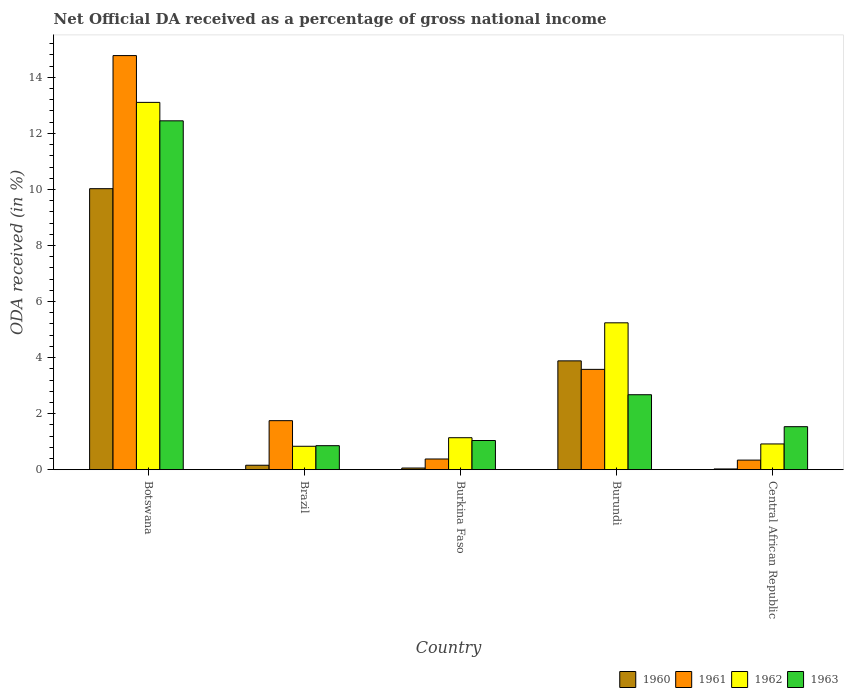How many groups of bars are there?
Your answer should be compact. 5. Are the number of bars per tick equal to the number of legend labels?
Your answer should be very brief. Yes. How many bars are there on the 5th tick from the left?
Give a very brief answer. 4. What is the label of the 2nd group of bars from the left?
Your answer should be compact. Brazil. In how many cases, is the number of bars for a given country not equal to the number of legend labels?
Offer a very short reply. 0. What is the net official DA received in 1963 in Burkina Faso?
Keep it short and to the point. 1.04. Across all countries, what is the maximum net official DA received in 1961?
Give a very brief answer. 14.78. Across all countries, what is the minimum net official DA received in 1960?
Your response must be concise. 0.03. In which country was the net official DA received in 1960 maximum?
Give a very brief answer. Botswana. In which country was the net official DA received in 1962 minimum?
Your response must be concise. Brazil. What is the total net official DA received in 1961 in the graph?
Your answer should be very brief. 20.83. What is the difference between the net official DA received in 1963 in Burkina Faso and that in Burundi?
Provide a short and direct response. -1.63. What is the difference between the net official DA received in 1960 in Botswana and the net official DA received in 1961 in Brazil?
Your answer should be compact. 8.28. What is the average net official DA received in 1963 per country?
Provide a succinct answer. 3.71. What is the difference between the net official DA received of/in 1963 and net official DA received of/in 1960 in Botswana?
Your answer should be compact. 2.42. What is the ratio of the net official DA received in 1962 in Botswana to that in Burundi?
Offer a terse response. 2.5. Is the difference between the net official DA received in 1963 in Burundi and Central African Republic greater than the difference between the net official DA received in 1960 in Burundi and Central African Republic?
Provide a succinct answer. No. What is the difference between the highest and the second highest net official DA received in 1961?
Give a very brief answer. -1.83. What is the difference between the highest and the lowest net official DA received in 1961?
Give a very brief answer. 14.43. Is it the case that in every country, the sum of the net official DA received in 1962 and net official DA received in 1961 is greater than the sum of net official DA received in 1960 and net official DA received in 1963?
Your response must be concise. No. Is it the case that in every country, the sum of the net official DA received in 1963 and net official DA received in 1962 is greater than the net official DA received in 1961?
Your answer should be compact. No. How many bars are there?
Ensure brevity in your answer.  20. Are all the bars in the graph horizontal?
Provide a succinct answer. No. How many countries are there in the graph?
Provide a short and direct response. 5. What is the difference between two consecutive major ticks on the Y-axis?
Make the answer very short. 2. Does the graph contain any zero values?
Offer a terse response. No. Does the graph contain grids?
Offer a terse response. No. How are the legend labels stacked?
Offer a very short reply. Horizontal. What is the title of the graph?
Make the answer very short. Net Official DA received as a percentage of gross national income. What is the label or title of the X-axis?
Your answer should be compact. Country. What is the label or title of the Y-axis?
Give a very brief answer. ODA received (in %). What is the ODA received (in %) in 1960 in Botswana?
Ensure brevity in your answer.  10.03. What is the ODA received (in %) of 1961 in Botswana?
Ensure brevity in your answer.  14.78. What is the ODA received (in %) in 1962 in Botswana?
Provide a succinct answer. 13.11. What is the ODA received (in %) of 1963 in Botswana?
Your response must be concise. 12.45. What is the ODA received (in %) in 1960 in Brazil?
Make the answer very short. 0.16. What is the ODA received (in %) of 1961 in Brazil?
Provide a short and direct response. 1.75. What is the ODA received (in %) in 1962 in Brazil?
Provide a succinct answer. 0.84. What is the ODA received (in %) in 1963 in Brazil?
Give a very brief answer. 0.86. What is the ODA received (in %) of 1960 in Burkina Faso?
Your answer should be very brief. 0.06. What is the ODA received (in %) in 1961 in Burkina Faso?
Your answer should be compact. 0.38. What is the ODA received (in %) in 1962 in Burkina Faso?
Provide a succinct answer. 1.14. What is the ODA received (in %) of 1963 in Burkina Faso?
Your answer should be very brief. 1.04. What is the ODA received (in %) in 1960 in Burundi?
Your answer should be compact. 3.88. What is the ODA received (in %) in 1961 in Burundi?
Your response must be concise. 3.58. What is the ODA received (in %) of 1962 in Burundi?
Provide a short and direct response. 5.24. What is the ODA received (in %) of 1963 in Burundi?
Make the answer very short. 2.68. What is the ODA received (in %) in 1960 in Central African Republic?
Keep it short and to the point. 0.03. What is the ODA received (in %) in 1961 in Central African Republic?
Your response must be concise. 0.34. What is the ODA received (in %) of 1962 in Central African Republic?
Your answer should be compact. 0.92. What is the ODA received (in %) of 1963 in Central African Republic?
Offer a very short reply. 1.54. Across all countries, what is the maximum ODA received (in %) in 1960?
Your answer should be very brief. 10.03. Across all countries, what is the maximum ODA received (in %) of 1961?
Provide a short and direct response. 14.78. Across all countries, what is the maximum ODA received (in %) of 1962?
Your answer should be compact. 13.11. Across all countries, what is the maximum ODA received (in %) of 1963?
Keep it short and to the point. 12.45. Across all countries, what is the minimum ODA received (in %) in 1960?
Your answer should be very brief. 0.03. Across all countries, what is the minimum ODA received (in %) in 1961?
Your answer should be very brief. 0.34. Across all countries, what is the minimum ODA received (in %) in 1962?
Provide a succinct answer. 0.84. Across all countries, what is the minimum ODA received (in %) in 1963?
Ensure brevity in your answer.  0.86. What is the total ODA received (in %) of 1960 in the graph?
Offer a very short reply. 14.16. What is the total ODA received (in %) of 1961 in the graph?
Your answer should be very brief. 20.83. What is the total ODA received (in %) in 1962 in the graph?
Your response must be concise. 21.24. What is the total ODA received (in %) in 1963 in the graph?
Provide a succinct answer. 18.56. What is the difference between the ODA received (in %) of 1960 in Botswana and that in Brazil?
Ensure brevity in your answer.  9.87. What is the difference between the ODA received (in %) in 1961 in Botswana and that in Brazil?
Your answer should be compact. 13.03. What is the difference between the ODA received (in %) of 1962 in Botswana and that in Brazil?
Keep it short and to the point. 12.27. What is the difference between the ODA received (in %) of 1963 in Botswana and that in Brazil?
Ensure brevity in your answer.  11.59. What is the difference between the ODA received (in %) of 1960 in Botswana and that in Burkina Faso?
Offer a terse response. 9.97. What is the difference between the ODA received (in %) of 1961 in Botswana and that in Burkina Faso?
Keep it short and to the point. 14.39. What is the difference between the ODA received (in %) of 1962 in Botswana and that in Burkina Faso?
Your answer should be compact. 11.97. What is the difference between the ODA received (in %) in 1963 in Botswana and that in Burkina Faso?
Your answer should be very brief. 11.41. What is the difference between the ODA received (in %) in 1960 in Botswana and that in Burundi?
Make the answer very short. 6.14. What is the difference between the ODA received (in %) of 1961 in Botswana and that in Burundi?
Ensure brevity in your answer.  11.2. What is the difference between the ODA received (in %) in 1962 in Botswana and that in Burundi?
Make the answer very short. 7.87. What is the difference between the ODA received (in %) of 1963 in Botswana and that in Burundi?
Provide a short and direct response. 9.77. What is the difference between the ODA received (in %) of 1960 in Botswana and that in Central African Republic?
Offer a very short reply. 10. What is the difference between the ODA received (in %) in 1961 in Botswana and that in Central African Republic?
Ensure brevity in your answer.  14.43. What is the difference between the ODA received (in %) of 1962 in Botswana and that in Central African Republic?
Your answer should be compact. 12.19. What is the difference between the ODA received (in %) in 1963 in Botswana and that in Central African Republic?
Your answer should be very brief. 10.91. What is the difference between the ODA received (in %) in 1960 in Brazil and that in Burkina Faso?
Offer a terse response. 0.1. What is the difference between the ODA received (in %) in 1961 in Brazil and that in Burkina Faso?
Make the answer very short. 1.37. What is the difference between the ODA received (in %) of 1962 in Brazil and that in Burkina Faso?
Your response must be concise. -0.31. What is the difference between the ODA received (in %) of 1963 in Brazil and that in Burkina Faso?
Give a very brief answer. -0.18. What is the difference between the ODA received (in %) of 1960 in Brazil and that in Burundi?
Give a very brief answer. -3.72. What is the difference between the ODA received (in %) of 1961 in Brazil and that in Burundi?
Ensure brevity in your answer.  -1.83. What is the difference between the ODA received (in %) in 1962 in Brazil and that in Burundi?
Provide a succinct answer. -4.41. What is the difference between the ODA received (in %) of 1963 in Brazil and that in Burundi?
Offer a terse response. -1.82. What is the difference between the ODA received (in %) in 1960 in Brazil and that in Central African Republic?
Offer a terse response. 0.13. What is the difference between the ODA received (in %) in 1961 in Brazil and that in Central African Republic?
Ensure brevity in your answer.  1.41. What is the difference between the ODA received (in %) in 1962 in Brazil and that in Central African Republic?
Provide a short and direct response. -0.08. What is the difference between the ODA received (in %) of 1963 in Brazil and that in Central African Republic?
Give a very brief answer. -0.68. What is the difference between the ODA received (in %) in 1960 in Burkina Faso and that in Burundi?
Provide a short and direct response. -3.82. What is the difference between the ODA received (in %) of 1961 in Burkina Faso and that in Burundi?
Offer a very short reply. -3.2. What is the difference between the ODA received (in %) of 1962 in Burkina Faso and that in Burundi?
Ensure brevity in your answer.  -4.1. What is the difference between the ODA received (in %) in 1963 in Burkina Faso and that in Burundi?
Provide a succinct answer. -1.63. What is the difference between the ODA received (in %) in 1960 in Burkina Faso and that in Central African Republic?
Ensure brevity in your answer.  0.03. What is the difference between the ODA received (in %) in 1961 in Burkina Faso and that in Central African Republic?
Make the answer very short. 0.04. What is the difference between the ODA received (in %) in 1962 in Burkina Faso and that in Central African Republic?
Provide a short and direct response. 0.22. What is the difference between the ODA received (in %) of 1963 in Burkina Faso and that in Central African Republic?
Provide a succinct answer. -0.49. What is the difference between the ODA received (in %) of 1960 in Burundi and that in Central African Republic?
Ensure brevity in your answer.  3.86. What is the difference between the ODA received (in %) of 1961 in Burundi and that in Central African Republic?
Make the answer very short. 3.24. What is the difference between the ODA received (in %) in 1962 in Burundi and that in Central African Republic?
Offer a very short reply. 4.32. What is the difference between the ODA received (in %) of 1963 in Burundi and that in Central African Republic?
Offer a terse response. 1.14. What is the difference between the ODA received (in %) in 1960 in Botswana and the ODA received (in %) in 1961 in Brazil?
Provide a succinct answer. 8.28. What is the difference between the ODA received (in %) in 1960 in Botswana and the ODA received (in %) in 1962 in Brazil?
Provide a short and direct response. 9.19. What is the difference between the ODA received (in %) of 1960 in Botswana and the ODA received (in %) of 1963 in Brazil?
Offer a terse response. 9.17. What is the difference between the ODA received (in %) of 1961 in Botswana and the ODA received (in %) of 1962 in Brazil?
Provide a short and direct response. 13.94. What is the difference between the ODA received (in %) in 1961 in Botswana and the ODA received (in %) in 1963 in Brazil?
Give a very brief answer. 13.92. What is the difference between the ODA received (in %) of 1962 in Botswana and the ODA received (in %) of 1963 in Brazil?
Provide a short and direct response. 12.25. What is the difference between the ODA received (in %) in 1960 in Botswana and the ODA received (in %) in 1961 in Burkina Faso?
Make the answer very short. 9.65. What is the difference between the ODA received (in %) of 1960 in Botswana and the ODA received (in %) of 1962 in Burkina Faso?
Your response must be concise. 8.89. What is the difference between the ODA received (in %) in 1960 in Botswana and the ODA received (in %) in 1963 in Burkina Faso?
Your answer should be compact. 8.99. What is the difference between the ODA received (in %) of 1961 in Botswana and the ODA received (in %) of 1962 in Burkina Faso?
Provide a succinct answer. 13.64. What is the difference between the ODA received (in %) in 1961 in Botswana and the ODA received (in %) in 1963 in Burkina Faso?
Offer a very short reply. 13.74. What is the difference between the ODA received (in %) in 1962 in Botswana and the ODA received (in %) in 1963 in Burkina Faso?
Give a very brief answer. 12.07. What is the difference between the ODA received (in %) in 1960 in Botswana and the ODA received (in %) in 1961 in Burundi?
Your answer should be very brief. 6.45. What is the difference between the ODA received (in %) in 1960 in Botswana and the ODA received (in %) in 1962 in Burundi?
Offer a very short reply. 4.79. What is the difference between the ODA received (in %) in 1960 in Botswana and the ODA received (in %) in 1963 in Burundi?
Your response must be concise. 7.35. What is the difference between the ODA received (in %) in 1961 in Botswana and the ODA received (in %) in 1962 in Burundi?
Offer a terse response. 9.54. What is the difference between the ODA received (in %) in 1961 in Botswana and the ODA received (in %) in 1963 in Burundi?
Offer a terse response. 12.1. What is the difference between the ODA received (in %) in 1962 in Botswana and the ODA received (in %) in 1963 in Burundi?
Offer a terse response. 10.43. What is the difference between the ODA received (in %) of 1960 in Botswana and the ODA received (in %) of 1961 in Central African Republic?
Your answer should be compact. 9.69. What is the difference between the ODA received (in %) of 1960 in Botswana and the ODA received (in %) of 1962 in Central African Republic?
Give a very brief answer. 9.11. What is the difference between the ODA received (in %) of 1960 in Botswana and the ODA received (in %) of 1963 in Central African Republic?
Give a very brief answer. 8.49. What is the difference between the ODA received (in %) of 1961 in Botswana and the ODA received (in %) of 1962 in Central African Republic?
Your answer should be compact. 13.86. What is the difference between the ODA received (in %) of 1961 in Botswana and the ODA received (in %) of 1963 in Central African Republic?
Your answer should be compact. 13.24. What is the difference between the ODA received (in %) of 1962 in Botswana and the ODA received (in %) of 1963 in Central African Republic?
Give a very brief answer. 11.57. What is the difference between the ODA received (in %) in 1960 in Brazil and the ODA received (in %) in 1961 in Burkina Faso?
Make the answer very short. -0.22. What is the difference between the ODA received (in %) of 1960 in Brazil and the ODA received (in %) of 1962 in Burkina Faso?
Your answer should be very brief. -0.98. What is the difference between the ODA received (in %) in 1960 in Brazil and the ODA received (in %) in 1963 in Burkina Faso?
Keep it short and to the point. -0.88. What is the difference between the ODA received (in %) of 1961 in Brazil and the ODA received (in %) of 1962 in Burkina Faso?
Keep it short and to the point. 0.61. What is the difference between the ODA received (in %) of 1961 in Brazil and the ODA received (in %) of 1963 in Burkina Faso?
Offer a terse response. 0.71. What is the difference between the ODA received (in %) of 1962 in Brazil and the ODA received (in %) of 1963 in Burkina Faso?
Ensure brevity in your answer.  -0.21. What is the difference between the ODA received (in %) of 1960 in Brazil and the ODA received (in %) of 1961 in Burundi?
Give a very brief answer. -3.42. What is the difference between the ODA received (in %) of 1960 in Brazil and the ODA received (in %) of 1962 in Burundi?
Ensure brevity in your answer.  -5.08. What is the difference between the ODA received (in %) in 1960 in Brazil and the ODA received (in %) in 1963 in Burundi?
Keep it short and to the point. -2.52. What is the difference between the ODA received (in %) in 1961 in Brazil and the ODA received (in %) in 1962 in Burundi?
Your response must be concise. -3.49. What is the difference between the ODA received (in %) of 1961 in Brazil and the ODA received (in %) of 1963 in Burundi?
Offer a terse response. -0.93. What is the difference between the ODA received (in %) in 1962 in Brazil and the ODA received (in %) in 1963 in Burundi?
Offer a very short reply. -1.84. What is the difference between the ODA received (in %) of 1960 in Brazil and the ODA received (in %) of 1961 in Central African Republic?
Your answer should be very brief. -0.18. What is the difference between the ODA received (in %) in 1960 in Brazil and the ODA received (in %) in 1962 in Central African Republic?
Your answer should be compact. -0.76. What is the difference between the ODA received (in %) in 1960 in Brazil and the ODA received (in %) in 1963 in Central African Republic?
Keep it short and to the point. -1.38. What is the difference between the ODA received (in %) of 1961 in Brazil and the ODA received (in %) of 1962 in Central African Republic?
Offer a very short reply. 0.83. What is the difference between the ODA received (in %) in 1961 in Brazil and the ODA received (in %) in 1963 in Central African Republic?
Offer a terse response. 0.21. What is the difference between the ODA received (in %) in 1962 in Brazil and the ODA received (in %) in 1963 in Central African Republic?
Your response must be concise. -0.7. What is the difference between the ODA received (in %) of 1960 in Burkina Faso and the ODA received (in %) of 1961 in Burundi?
Provide a short and direct response. -3.52. What is the difference between the ODA received (in %) of 1960 in Burkina Faso and the ODA received (in %) of 1962 in Burundi?
Your response must be concise. -5.18. What is the difference between the ODA received (in %) of 1960 in Burkina Faso and the ODA received (in %) of 1963 in Burundi?
Your response must be concise. -2.62. What is the difference between the ODA received (in %) in 1961 in Burkina Faso and the ODA received (in %) in 1962 in Burundi?
Your answer should be compact. -4.86. What is the difference between the ODA received (in %) of 1961 in Burkina Faso and the ODA received (in %) of 1963 in Burundi?
Provide a short and direct response. -2.29. What is the difference between the ODA received (in %) of 1962 in Burkina Faso and the ODA received (in %) of 1963 in Burundi?
Your answer should be very brief. -1.53. What is the difference between the ODA received (in %) of 1960 in Burkina Faso and the ODA received (in %) of 1961 in Central African Republic?
Offer a very short reply. -0.28. What is the difference between the ODA received (in %) in 1960 in Burkina Faso and the ODA received (in %) in 1962 in Central African Republic?
Offer a very short reply. -0.86. What is the difference between the ODA received (in %) in 1960 in Burkina Faso and the ODA received (in %) in 1963 in Central African Republic?
Provide a succinct answer. -1.48. What is the difference between the ODA received (in %) of 1961 in Burkina Faso and the ODA received (in %) of 1962 in Central African Republic?
Your answer should be compact. -0.54. What is the difference between the ODA received (in %) of 1961 in Burkina Faso and the ODA received (in %) of 1963 in Central African Republic?
Ensure brevity in your answer.  -1.15. What is the difference between the ODA received (in %) in 1962 in Burkina Faso and the ODA received (in %) in 1963 in Central African Republic?
Provide a short and direct response. -0.39. What is the difference between the ODA received (in %) in 1960 in Burundi and the ODA received (in %) in 1961 in Central African Republic?
Your answer should be very brief. 3.54. What is the difference between the ODA received (in %) of 1960 in Burundi and the ODA received (in %) of 1962 in Central African Republic?
Provide a short and direct response. 2.96. What is the difference between the ODA received (in %) of 1960 in Burundi and the ODA received (in %) of 1963 in Central African Republic?
Your answer should be very brief. 2.35. What is the difference between the ODA received (in %) in 1961 in Burundi and the ODA received (in %) in 1962 in Central African Republic?
Give a very brief answer. 2.66. What is the difference between the ODA received (in %) in 1961 in Burundi and the ODA received (in %) in 1963 in Central African Republic?
Make the answer very short. 2.05. What is the difference between the ODA received (in %) in 1962 in Burundi and the ODA received (in %) in 1963 in Central African Republic?
Offer a terse response. 3.71. What is the average ODA received (in %) of 1960 per country?
Offer a terse response. 2.83. What is the average ODA received (in %) in 1961 per country?
Provide a short and direct response. 4.17. What is the average ODA received (in %) in 1962 per country?
Offer a very short reply. 4.25. What is the average ODA received (in %) in 1963 per country?
Give a very brief answer. 3.71. What is the difference between the ODA received (in %) in 1960 and ODA received (in %) in 1961 in Botswana?
Your answer should be compact. -4.75. What is the difference between the ODA received (in %) in 1960 and ODA received (in %) in 1962 in Botswana?
Keep it short and to the point. -3.08. What is the difference between the ODA received (in %) in 1960 and ODA received (in %) in 1963 in Botswana?
Make the answer very short. -2.42. What is the difference between the ODA received (in %) of 1961 and ODA received (in %) of 1962 in Botswana?
Provide a succinct answer. 1.67. What is the difference between the ODA received (in %) of 1961 and ODA received (in %) of 1963 in Botswana?
Your answer should be compact. 2.33. What is the difference between the ODA received (in %) in 1962 and ODA received (in %) in 1963 in Botswana?
Provide a succinct answer. 0.66. What is the difference between the ODA received (in %) of 1960 and ODA received (in %) of 1961 in Brazil?
Give a very brief answer. -1.59. What is the difference between the ODA received (in %) of 1960 and ODA received (in %) of 1962 in Brazil?
Your response must be concise. -0.68. What is the difference between the ODA received (in %) in 1960 and ODA received (in %) in 1963 in Brazil?
Your answer should be very brief. -0.7. What is the difference between the ODA received (in %) of 1961 and ODA received (in %) of 1962 in Brazil?
Give a very brief answer. 0.91. What is the difference between the ODA received (in %) in 1961 and ODA received (in %) in 1963 in Brazil?
Ensure brevity in your answer.  0.89. What is the difference between the ODA received (in %) of 1962 and ODA received (in %) of 1963 in Brazil?
Give a very brief answer. -0.02. What is the difference between the ODA received (in %) in 1960 and ODA received (in %) in 1961 in Burkina Faso?
Offer a terse response. -0.32. What is the difference between the ODA received (in %) in 1960 and ODA received (in %) in 1962 in Burkina Faso?
Your answer should be very brief. -1.08. What is the difference between the ODA received (in %) in 1960 and ODA received (in %) in 1963 in Burkina Faso?
Offer a terse response. -0.98. What is the difference between the ODA received (in %) in 1961 and ODA received (in %) in 1962 in Burkina Faso?
Your answer should be compact. -0.76. What is the difference between the ODA received (in %) of 1961 and ODA received (in %) of 1963 in Burkina Faso?
Ensure brevity in your answer.  -0.66. What is the difference between the ODA received (in %) in 1960 and ODA received (in %) in 1961 in Burundi?
Ensure brevity in your answer.  0.3. What is the difference between the ODA received (in %) of 1960 and ODA received (in %) of 1962 in Burundi?
Your response must be concise. -1.36. What is the difference between the ODA received (in %) in 1960 and ODA received (in %) in 1963 in Burundi?
Provide a succinct answer. 1.21. What is the difference between the ODA received (in %) in 1961 and ODA received (in %) in 1962 in Burundi?
Provide a short and direct response. -1.66. What is the difference between the ODA received (in %) in 1961 and ODA received (in %) in 1963 in Burundi?
Ensure brevity in your answer.  0.91. What is the difference between the ODA received (in %) of 1962 and ODA received (in %) of 1963 in Burundi?
Offer a very short reply. 2.57. What is the difference between the ODA received (in %) in 1960 and ODA received (in %) in 1961 in Central African Republic?
Ensure brevity in your answer.  -0.32. What is the difference between the ODA received (in %) of 1960 and ODA received (in %) of 1962 in Central African Republic?
Your response must be concise. -0.89. What is the difference between the ODA received (in %) in 1960 and ODA received (in %) in 1963 in Central African Republic?
Provide a short and direct response. -1.51. What is the difference between the ODA received (in %) in 1961 and ODA received (in %) in 1962 in Central African Republic?
Your response must be concise. -0.58. What is the difference between the ODA received (in %) in 1961 and ODA received (in %) in 1963 in Central African Republic?
Your answer should be compact. -1.19. What is the difference between the ODA received (in %) of 1962 and ODA received (in %) of 1963 in Central African Republic?
Your answer should be very brief. -0.62. What is the ratio of the ODA received (in %) of 1960 in Botswana to that in Brazil?
Give a very brief answer. 63.08. What is the ratio of the ODA received (in %) in 1961 in Botswana to that in Brazil?
Keep it short and to the point. 8.45. What is the ratio of the ODA received (in %) in 1962 in Botswana to that in Brazil?
Keep it short and to the point. 15.68. What is the ratio of the ODA received (in %) of 1963 in Botswana to that in Brazil?
Keep it short and to the point. 14.53. What is the ratio of the ODA received (in %) of 1960 in Botswana to that in Burkina Faso?
Make the answer very short. 167.91. What is the ratio of the ODA received (in %) in 1961 in Botswana to that in Burkina Faso?
Provide a succinct answer. 38.69. What is the ratio of the ODA received (in %) of 1962 in Botswana to that in Burkina Faso?
Give a very brief answer. 11.48. What is the ratio of the ODA received (in %) in 1963 in Botswana to that in Burkina Faso?
Make the answer very short. 11.95. What is the ratio of the ODA received (in %) of 1960 in Botswana to that in Burundi?
Give a very brief answer. 2.58. What is the ratio of the ODA received (in %) in 1961 in Botswana to that in Burundi?
Your answer should be very brief. 4.13. What is the ratio of the ODA received (in %) of 1962 in Botswana to that in Burundi?
Offer a very short reply. 2.5. What is the ratio of the ODA received (in %) of 1963 in Botswana to that in Burundi?
Make the answer very short. 4.65. What is the ratio of the ODA received (in %) in 1960 in Botswana to that in Central African Republic?
Your response must be concise. 373.52. What is the ratio of the ODA received (in %) in 1961 in Botswana to that in Central African Republic?
Your answer should be very brief. 43.18. What is the ratio of the ODA received (in %) of 1962 in Botswana to that in Central African Republic?
Offer a very short reply. 14.27. What is the ratio of the ODA received (in %) in 1963 in Botswana to that in Central African Republic?
Ensure brevity in your answer.  8.11. What is the ratio of the ODA received (in %) of 1960 in Brazil to that in Burkina Faso?
Your answer should be compact. 2.66. What is the ratio of the ODA received (in %) of 1961 in Brazil to that in Burkina Faso?
Your answer should be very brief. 4.58. What is the ratio of the ODA received (in %) in 1962 in Brazil to that in Burkina Faso?
Make the answer very short. 0.73. What is the ratio of the ODA received (in %) of 1963 in Brazil to that in Burkina Faso?
Make the answer very short. 0.82. What is the ratio of the ODA received (in %) in 1960 in Brazil to that in Burundi?
Provide a short and direct response. 0.04. What is the ratio of the ODA received (in %) in 1961 in Brazil to that in Burundi?
Provide a short and direct response. 0.49. What is the ratio of the ODA received (in %) of 1962 in Brazil to that in Burundi?
Your response must be concise. 0.16. What is the ratio of the ODA received (in %) in 1963 in Brazil to that in Burundi?
Your answer should be very brief. 0.32. What is the ratio of the ODA received (in %) in 1960 in Brazil to that in Central African Republic?
Offer a very short reply. 5.92. What is the ratio of the ODA received (in %) in 1961 in Brazil to that in Central African Republic?
Give a very brief answer. 5.11. What is the ratio of the ODA received (in %) of 1962 in Brazil to that in Central African Republic?
Give a very brief answer. 0.91. What is the ratio of the ODA received (in %) of 1963 in Brazil to that in Central African Republic?
Your response must be concise. 0.56. What is the ratio of the ODA received (in %) of 1960 in Burkina Faso to that in Burundi?
Your answer should be very brief. 0.02. What is the ratio of the ODA received (in %) of 1961 in Burkina Faso to that in Burundi?
Your answer should be compact. 0.11. What is the ratio of the ODA received (in %) of 1962 in Burkina Faso to that in Burundi?
Keep it short and to the point. 0.22. What is the ratio of the ODA received (in %) in 1963 in Burkina Faso to that in Burundi?
Your answer should be very brief. 0.39. What is the ratio of the ODA received (in %) of 1960 in Burkina Faso to that in Central African Republic?
Offer a very short reply. 2.22. What is the ratio of the ODA received (in %) in 1961 in Burkina Faso to that in Central African Republic?
Make the answer very short. 1.12. What is the ratio of the ODA received (in %) of 1962 in Burkina Faso to that in Central African Republic?
Give a very brief answer. 1.24. What is the ratio of the ODA received (in %) of 1963 in Burkina Faso to that in Central African Republic?
Give a very brief answer. 0.68. What is the ratio of the ODA received (in %) of 1960 in Burundi to that in Central African Republic?
Ensure brevity in your answer.  144.66. What is the ratio of the ODA received (in %) in 1961 in Burundi to that in Central African Republic?
Your answer should be compact. 10.46. What is the ratio of the ODA received (in %) in 1962 in Burundi to that in Central African Republic?
Give a very brief answer. 5.7. What is the ratio of the ODA received (in %) of 1963 in Burundi to that in Central African Republic?
Offer a very short reply. 1.74. What is the difference between the highest and the second highest ODA received (in %) of 1960?
Your response must be concise. 6.14. What is the difference between the highest and the second highest ODA received (in %) of 1961?
Your answer should be very brief. 11.2. What is the difference between the highest and the second highest ODA received (in %) of 1962?
Give a very brief answer. 7.87. What is the difference between the highest and the second highest ODA received (in %) in 1963?
Offer a very short reply. 9.77. What is the difference between the highest and the lowest ODA received (in %) of 1960?
Provide a succinct answer. 10. What is the difference between the highest and the lowest ODA received (in %) in 1961?
Make the answer very short. 14.43. What is the difference between the highest and the lowest ODA received (in %) of 1962?
Your answer should be compact. 12.27. What is the difference between the highest and the lowest ODA received (in %) of 1963?
Your response must be concise. 11.59. 